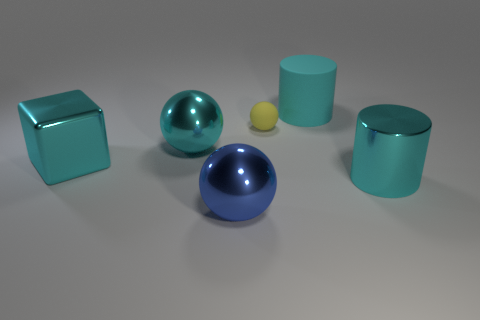There is a large cube that is the same color as the large matte cylinder; what is it made of?
Give a very brief answer. Metal. The big thing to the right of the cyan cylinder behind the cyan shiny cube is made of what material?
Offer a terse response. Metal. Are there any other rubber objects that have the same shape as the large blue thing?
Offer a very short reply. Yes. What number of other objects are the same shape as the blue object?
Give a very brief answer. 2. There is a big thing that is both on the right side of the rubber ball and in front of the big cyan block; what shape is it?
Offer a very short reply. Cylinder. What size is the object that is in front of the metal cylinder?
Offer a very short reply. Large. Is the cyan metal cylinder the same size as the cyan metal sphere?
Make the answer very short. Yes. Is the number of big cylinders left of the big blue ball less than the number of tiny yellow matte balls that are behind the cyan rubber thing?
Your answer should be compact. No. What is the size of the cyan metal thing that is both on the right side of the big cyan shiny block and in front of the large cyan sphere?
Offer a very short reply. Large. There is a big cylinder that is behind the big shiny thing on the right side of the large blue thing; is there a large blue thing to the left of it?
Your answer should be compact. Yes. 